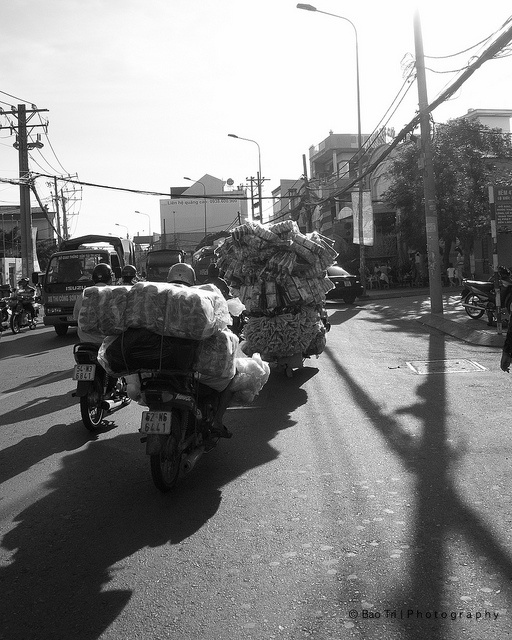Describe the objects in this image and their specific colors. I can see motorcycle in lightgray, black, gray, and darkgray tones, truck in lightgray, black, gray, white, and darkgray tones, motorcycle in lightgray, black, gray, and darkgray tones, motorcycle in lightgray, black, gray, and darkgray tones, and car in lightgray, black, gray, and darkgray tones in this image. 